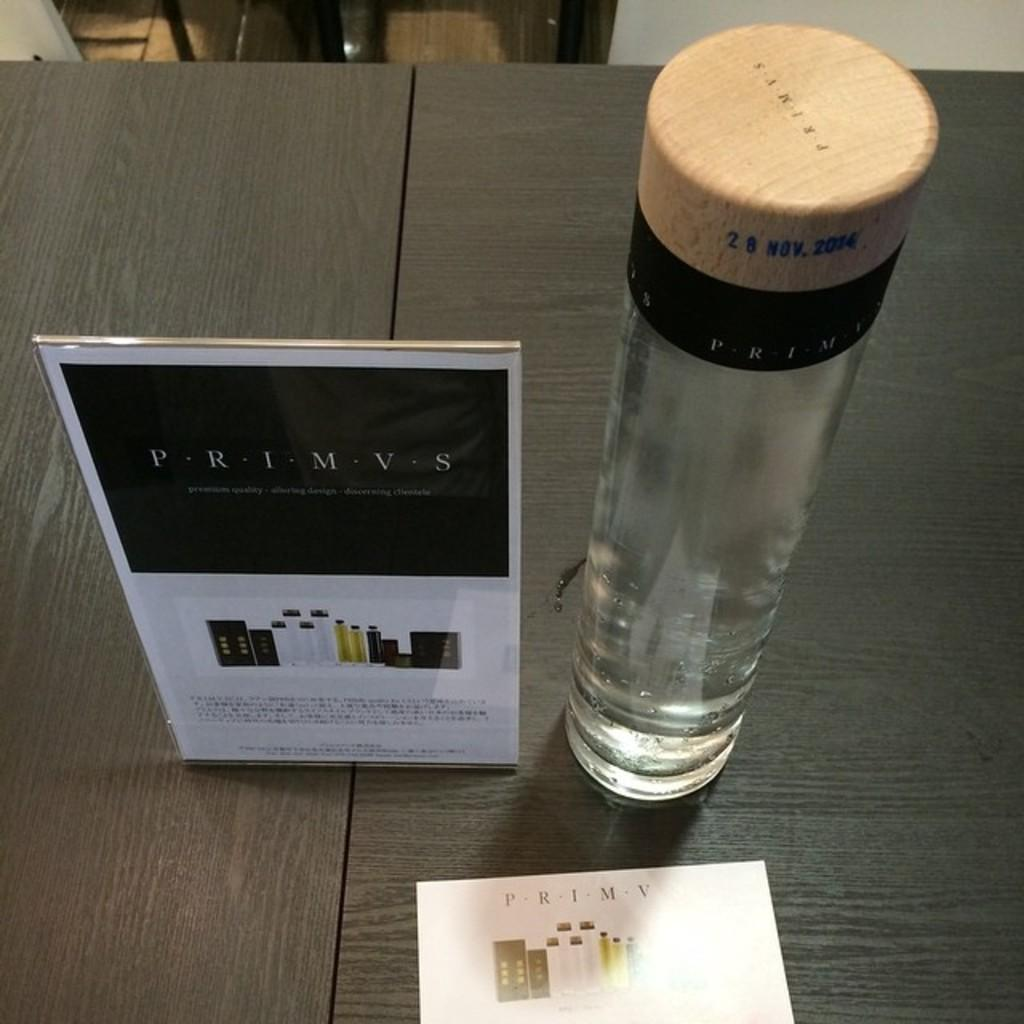<image>
Offer a succinct explanation of the picture presented. A Primvs logo sits on a table near a tube with the same markings. 